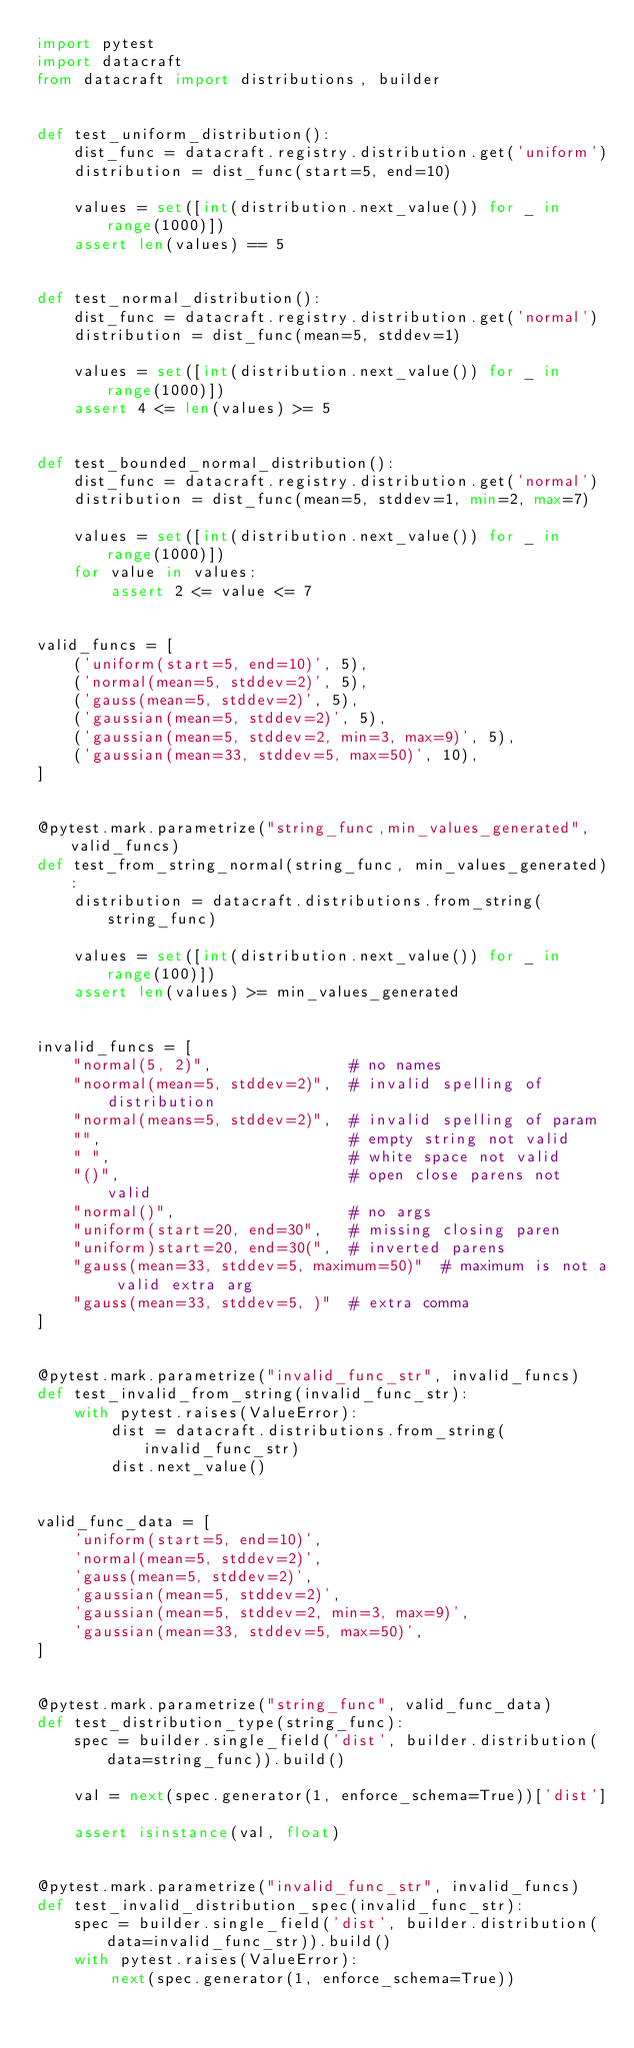<code> <loc_0><loc_0><loc_500><loc_500><_Python_>import pytest
import datacraft
from datacraft import distributions, builder


def test_uniform_distribution():
    dist_func = datacraft.registry.distribution.get('uniform')
    distribution = dist_func(start=5, end=10)

    values = set([int(distribution.next_value()) for _ in range(1000)])
    assert len(values) == 5


def test_normal_distribution():
    dist_func = datacraft.registry.distribution.get('normal')
    distribution = dist_func(mean=5, stddev=1)

    values = set([int(distribution.next_value()) for _ in range(1000)])
    assert 4 <= len(values) >= 5


def test_bounded_normal_distribution():
    dist_func = datacraft.registry.distribution.get('normal')
    distribution = dist_func(mean=5, stddev=1, min=2, max=7)

    values = set([int(distribution.next_value()) for _ in range(1000)])
    for value in values:
        assert 2 <= value <= 7


valid_funcs = [
    ('uniform(start=5, end=10)', 5),
    ('normal(mean=5, stddev=2)', 5),
    ('gauss(mean=5, stddev=2)', 5),
    ('gaussian(mean=5, stddev=2)', 5),
    ('gaussian(mean=5, stddev=2, min=3, max=9)', 5),
    ('gaussian(mean=33, stddev=5, max=50)', 10),
]


@pytest.mark.parametrize("string_func,min_values_generated", valid_funcs)
def test_from_string_normal(string_func, min_values_generated):
    distribution = datacraft.distributions.from_string(string_func)

    values = set([int(distribution.next_value()) for _ in range(100)])
    assert len(values) >= min_values_generated


invalid_funcs = [
    "normal(5, 2)",               # no names
    "noormal(mean=5, stddev=2)",  # invalid spelling of distribution
    "normal(means=5, stddev=2)",  # invalid spelling of param
    "",                           # empty string not valid
    " ",                          # white space not valid
    "()",                         # open close parens not valid
    "normal()",                   # no args
    "uniform(start=20, end=30",   # missing closing paren
    "uniform)start=20, end=30(",  # inverted parens
    "gauss(mean=33, stddev=5, maximum=50)"  # maximum is not a valid extra arg
    "gauss(mean=33, stddev=5, )"  # extra comma
]


@pytest.mark.parametrize("invalid_func_str", invalid_funcs)
def test_invalid_from_string(invalid_func_str):
    with pytest.raises(ValueError):
        dist = datacraft.distributions.from_string(invalid_func_str)
        dist.next_value()


valid_func_data = [
    'uniform(start=5, end=10)',
    'normal(mean=5, stddev=2)',
    'gauss(mean=5, stddev=2)',
    'gaussian(mean=5, stddev=2)',
    'gaussian(mean=5, stddev=2, min=3, max=9)',
    'gaussian(mean=33, stddev=5, max=50)',
]


@pytest.mark.parametrize("string_func", valid_func_data)
def test_distribution_type(string_func):
    spec = builder.single_field('dist', builder.distribution(data=string_func)).build()

    val = next(spec.generator(1, enforce_schema=True))['dist']

    assert isinstance(val, float)


@pytest.mark.parametrize("invalid_func_str", invalid_funcs)
def test_invalid_distribution_spec(invalid_func_str):
    spec = builder.single_field('dist', builder.distribution(data=invalid_func_str)).build()
    with pytest.raises(ValueError):
        next(spec.generator(1, enforce_schema=True))
</code> 